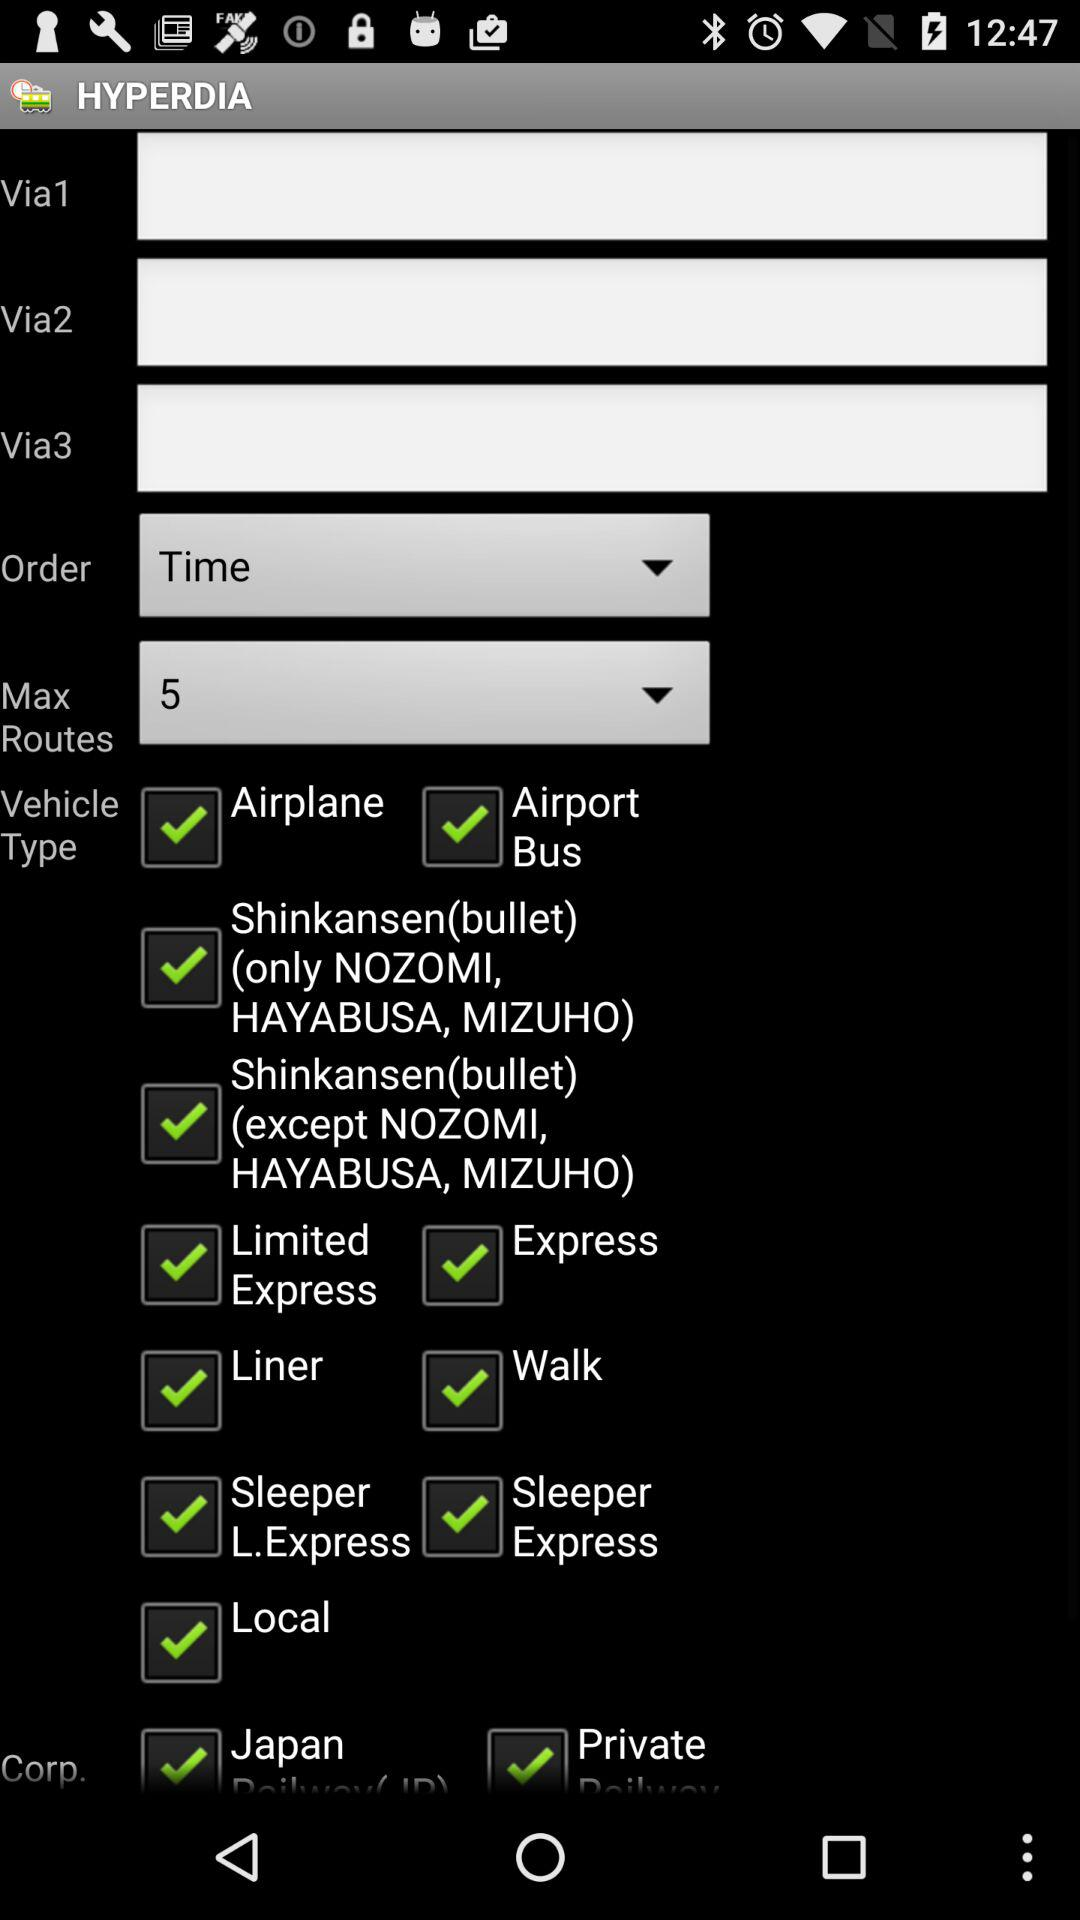What is selected in the "Max Routes"? In "Max Routes", 5 is selected. 